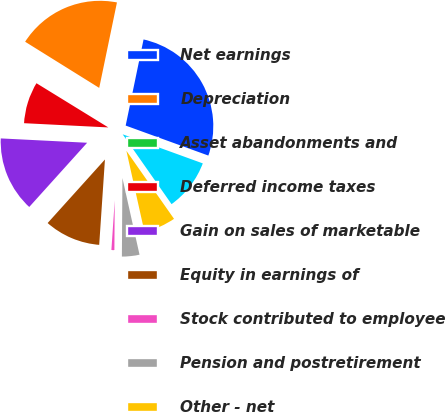Convert chart to OTSL. <chart><loc_0><loc_0><loc_500><loc_500><pie_chart><fcel>Net earnings<fcel>Depreciation<fcel>Asset abandonments and<fcel>Deferred income taxes<fcel>Gain on sales of marketable<fcel>Equity in earnings of<fcel>Stock contributed to employee<fcel>Pension and postretirement<fcel>Other - net<fcel>Segregated cash and<nl><fcel>27.28%<fcel>19.39%<fcel>0.09%<fcel>7.98%<fcel>14.12%<fcel>10.61%<fcel>0.96%<fcel>3.6%<fcel>6.23%<fcel>9.74%<nl></chart> 